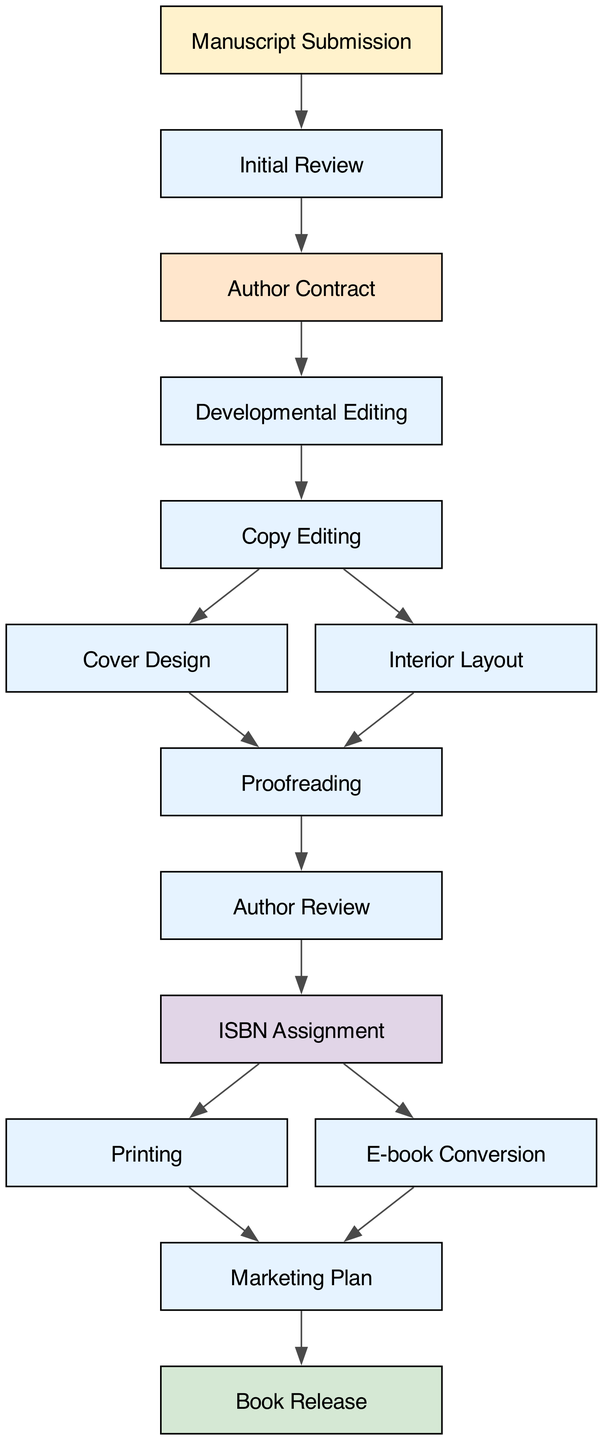What is the first step in the publishing process? The first step is "Manuscript Submission," which is where the process begins as authors submit their manuscripts.
Answer: Manuscript Submission How many stages are involved in the editing process? The editing process includes three stages: "Developmental Editing," "Copy Editing," and "Proofreading." This can be determined by counting the directed edges leading from the initial submission to the final review.
Answer: Three Which stage comes after "Author Review"? The stage that follows "Author Review" is "ISBN Assignment," indicating the sequencing of events in the publishing workflow.
Answer: ISBN Assignment What is the last node in the workflow? The last node in the workflow is "Book Release," which represents the final outcome of all previous stages in the publishing process.
Answer: Book Release How many nodes are there from "Copy Editing" to "Book Release"? There are four nodes from "Copy Editing" to "Book Release": "Cover Design," "Interior Layout," and "Marketing Plan," finally leading to "Book Release."
Answer: Four What is the relationship between "Proofreading" and "Author Review"? "Proofreading" directly leads to "Author Review," meaning it occurs prior to the author reviewing the final edits before publication.
Answer: Direct How many paths lead from "ISBN Assignment"? Two paths lead from "ISBN Assignment": one to "Printing" and one to "E-book Conversion," which shows the options available after this stage.
Answer: Two What is the purpose of the "Marketing Plan"? The "Marketing Plan" is essential for the promotion of the book and occurs after the printing and e-book conversion stages, prior to "Book Release."
Answer: Promotion Which stage is associated with the visual highlight color #D5E8D4? The highlight color #D5E8D4 is associated with the "Book Release" stage, suggesting its importance in the workflow as a final achievement.
Answer: Book Release 